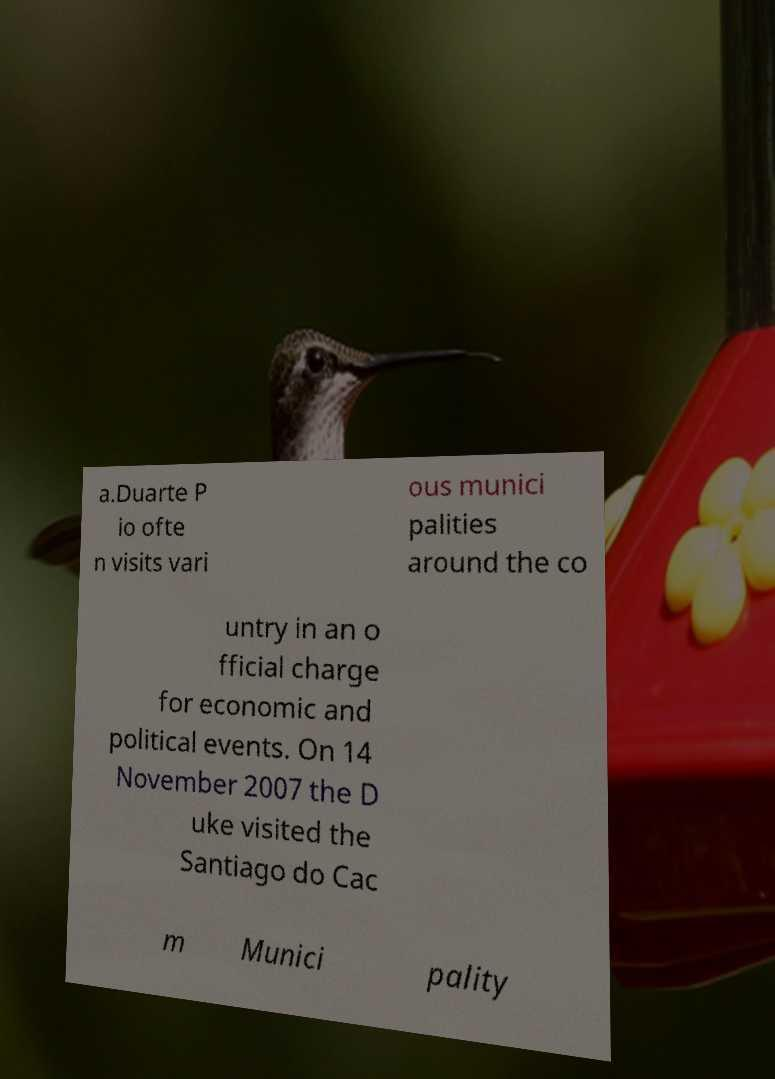I need the written content from this picture converted into text. Can you do that? a.Duarte P io ofte n visits vari ous munici palities around the co untry in an o fficial charge for economic and political events. On 14 November 2007 the D uke visited the Santiago do Cac m Munici pality 